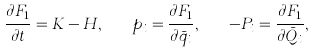Convert formula to latex. <formula><loc_0><loc_0><loc_500><loc_500>\frac { \partial F _ { 1 } } { \partial t } = K - H , \quad p _ { i } = \frac { \partial F _ { 1 } } { \partial \bar { q } _ { i } } , \quad - P _ { i } = \frac { \partial F _ { 1 } } { \partial \bar { Q } _ { i } } ,</formula> 